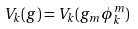<formula> <loc_0><loc_0><loc_500><loc_500>V _ { k } ( g ) = V _ { k } ( g _ { m } \phi _ { k } ^ { m } )</formula> 